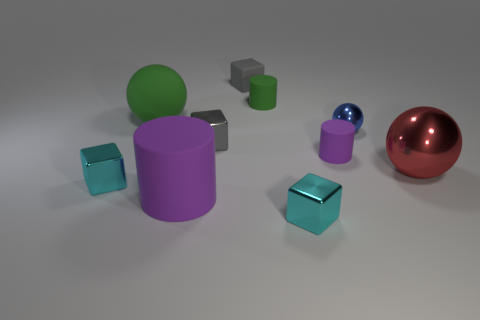Subtract all brown cubes. Subtract all brown balls. How many cubes are left? 4 Subtract all balls. How many objects are left? 7 Subtract 0 brown blocks. How many objects are left? 10 Subtract all tiny gray blocks. Subtract all gray metal blocks. How many objects are left? 7 Add 2 small gray shiny cubes. How many small gray shiny cubes are left? 3 Add 5 small gray shiny objects. How many small gray shiny objects exist? 6 